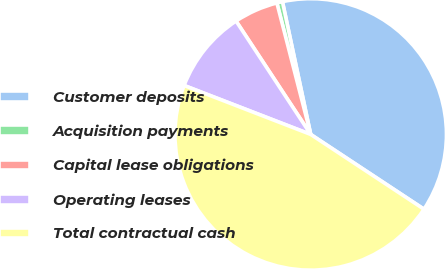Convert chart to OTSL. <chart><loc_0><loc_0><loc_500><loc_500><pie_chart><fcel>Customer deposits<fcel>Acquisition payments<fcel>Capital lease obligations<fcel>Operating leases<fcel>Total contractual cash<nl><fcel>37.62%<fcel>0.67%<fcel>5.26%<fcel>9.86%<fcel>46.58%<nl></chart> 